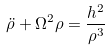Convert formula to latex. <formula><loc_0><loc_0><loc_500><loc_500>\ddot { \rho } + \Omega ^ { 2 } \rho = \frac { h ^ { 2 } } { \rho ^ { 3 } }</formula> 